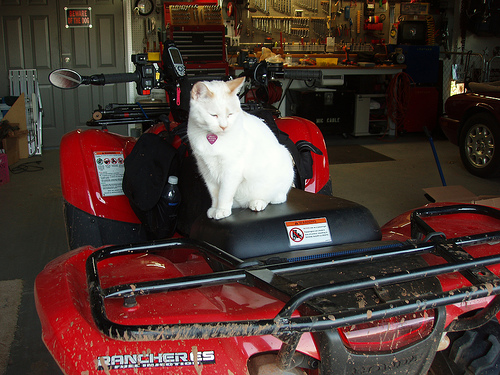<image>
Is there a white cat next to the red bike? No. The white cat is not positioned next to the red bike. They are located in different areas of the scene. 